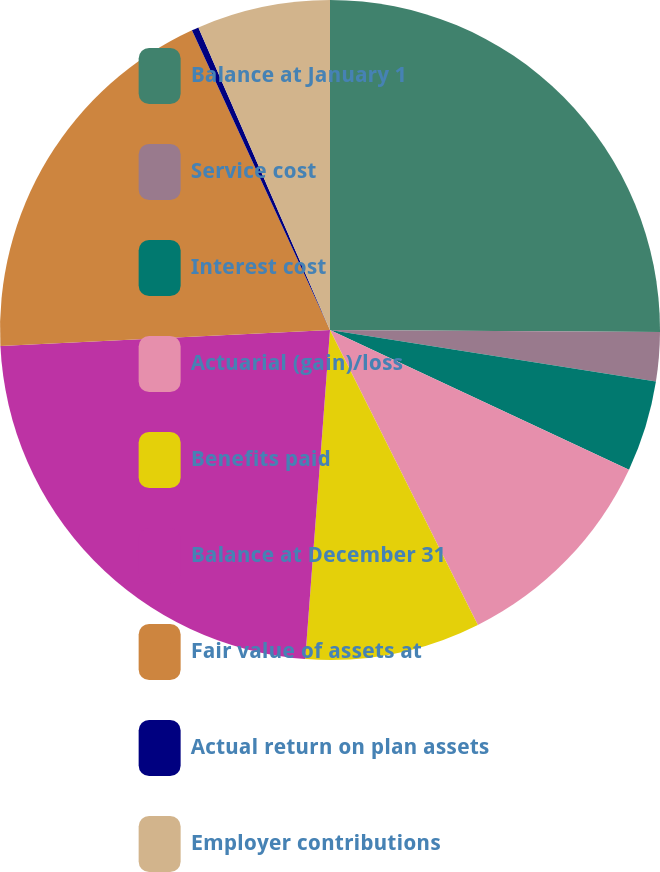<chart> <loc_0><loc_0><loc_500><loc_500><pie_chart><fcel>Balance at January 1<fcel>Service cost<fcel>Interest cost<fcel>Actuarial (gain)/loss<fcel>Benefits paid<fcel>Balance at December 31<fcel>Fair value of assets at<fcel>Actual return on plan assets<fcel>Employer contributions<nl><fcel>25.1%<fcel>2.4%<fcel>4.46%<fcel>10.65%<fcel>8.59%<fcel>23.03%<fcel>18.91%<fcel>0.34%<fcel>6.53%<nl></chart> 